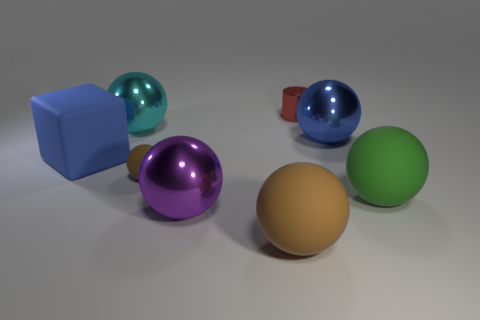Subtract all purple balls. How many balls are left? 5 Subtract all cyan spheres. How many spheres are left? 5 Subtract all gray spheres. Subtract all gray cubes. How many spheres are left? 6 Add 1 tiny metal balls. How many objects exist? 9 Subtract all blocks. How many objects are left? 7 Subtract all small red cylinders. Subtract all red cylinders. How many objects are left? 6 Add 3 rubber balls. How many rubber balls are left? 6 Add 2 big purple rubber things. How many big purple rubber things exist? 2 Subtract 0 gray blocks. How many objects are left? 8 